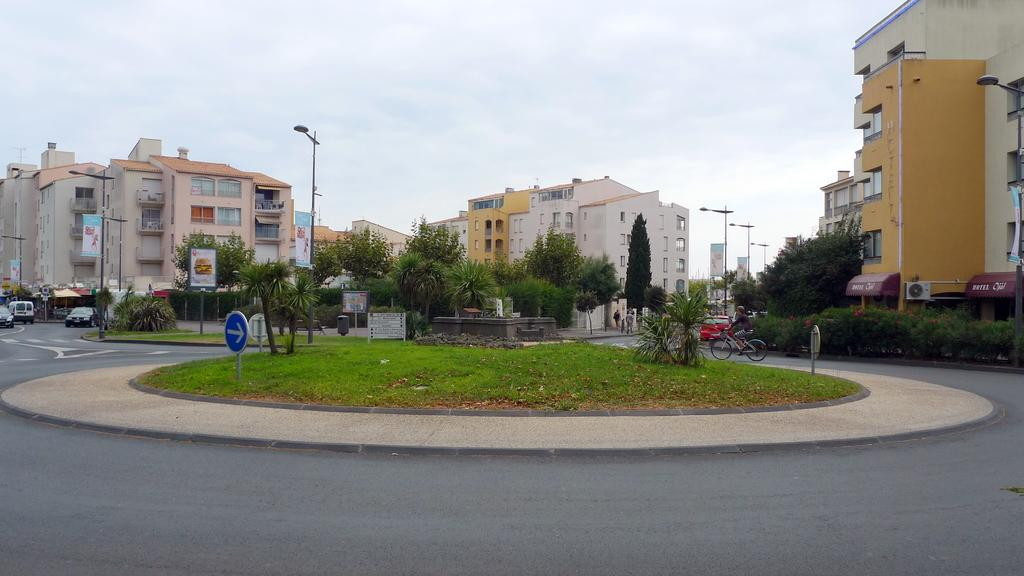What is the main feature of the image? There is a road in the image. What is happening on the road? There are vehicles moving on the road. What can be seen in the background of the image? There are trees and plants in the image. What structures are present along the road? There are street light poles in the image. How is the weather in the image? The sky is clear in the image. What type of stocking is hanging from the street light pole in the image? There is no stocking hanging from the street light pole in the image. What amusement park can be seen in the background of the image? There is no amusement park visible in the image; it features a road with vehicles, trees, plants, and street light poles. 